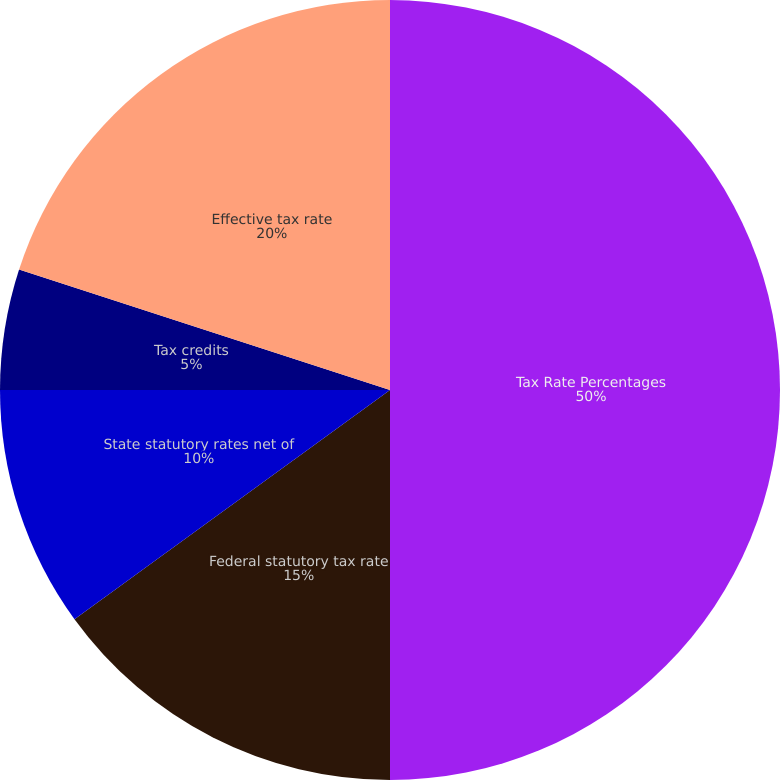Convert chart to OTSL. <chart><loc_0><loc_0><loc_500><loc_500><pie_chart><fcel>Tax Rate Percentages<fcel>Federal statutory tax rate<fcel>State statutory rates net of<fcel>Tax credits<fcel>Other<fcel>Effective tax rate<nl><fcel>50.0%<fcel>15.0%<fcel>10.0%<fcel>5.0%<fcel>0.0%<fcel>20.0%<nl></chart> 